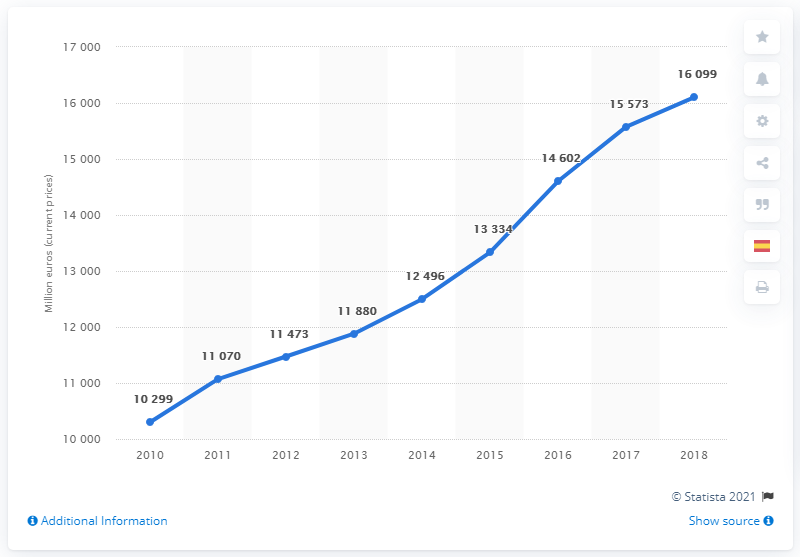Specify some key components in this picture. In 2018, the Gross Domestic Product (GDP) of the travel and tourism industry in the Canary Islands was 16,099 million euros. 